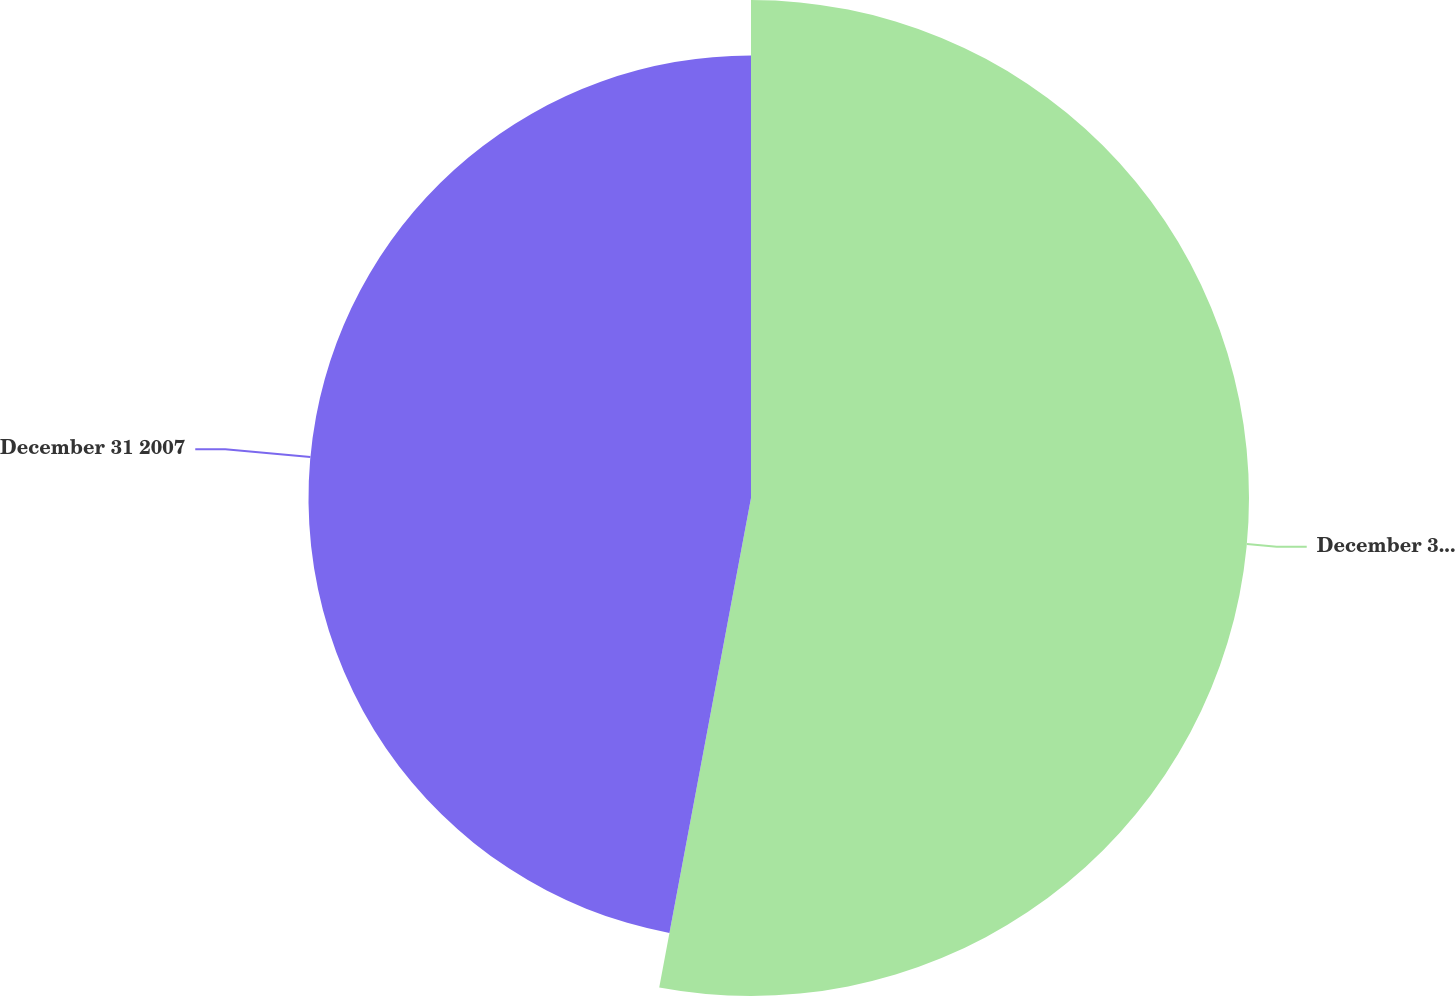<chart> <loc_0><loc_0><loc_500><loc_500><pie_chart><fcel>December 31 2006<fcel>December 31 2007<nl><fcel>52.95%<fcel>47.05%<nl></chart> 